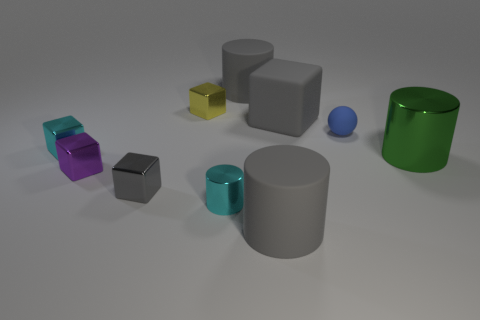Subtract 1 cubes. How many cubes are left? 4 Subtract all green cubes. Subtract all purple balls. How many cubes are left? 5 Subtract all cylinders. How many objects are left? 6 Add 8 green objects. How many green objects exist? 9 Subtract 0 green spheres. How many objects are left? 10 Subtract all green metal balls. Subtract all rubber spheres. How many objects are left? 9 Add 1 small purple objects. How many small purple objects are left? 2 